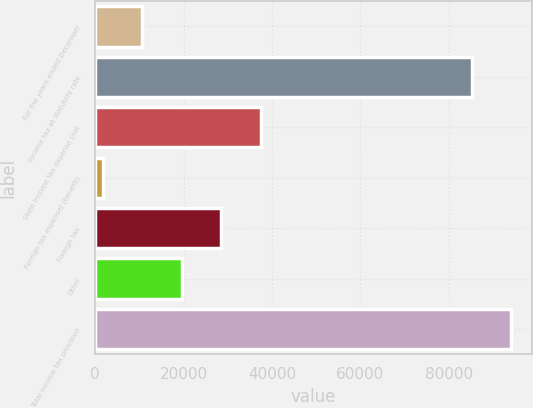<chart> <loc_0><loc_0><loc_500><loc_500><bar_chart><fcel>For the years ended December<fcel>Income tax at statutory rate<fcel>State income tax expense (net<fcel>Foreign tax expense/ (benefit)<fcel>Foreign tax<fcel>Other<fcel>Total income tax provision<nl><fcel>10659<fcel>85112<fcel>37449<fcel>1729<fcel>28519<fcel>19589<fcel>94042<nl></chart> 